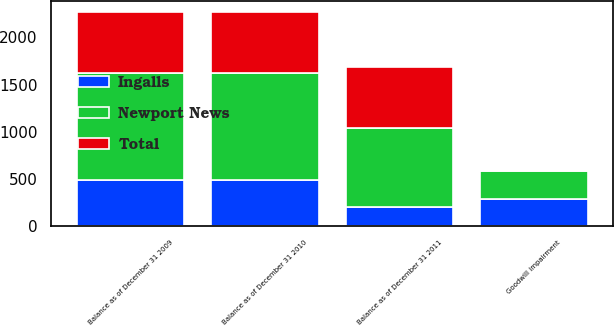<chart> <loc_0><loc_0><loc_500><loc_500><stacked_bar_chart><ecel><fcel>Balance as of December 31 2009<fcel>Balance as of December 31 2010<fcel>Goodwill impairment<fcel>Balance as of December 31 2011<nl><fcel>Ingalls<fcel>488<fcel>488<fcel>290<fcel>198<nl><fcel>Total<fcel>646<fcel>646<fcel>0<fcel>646<nl><fcel>Newport News<fcel>1134<fcel>1134<fcel>290<fcel>844<nl></chart> 